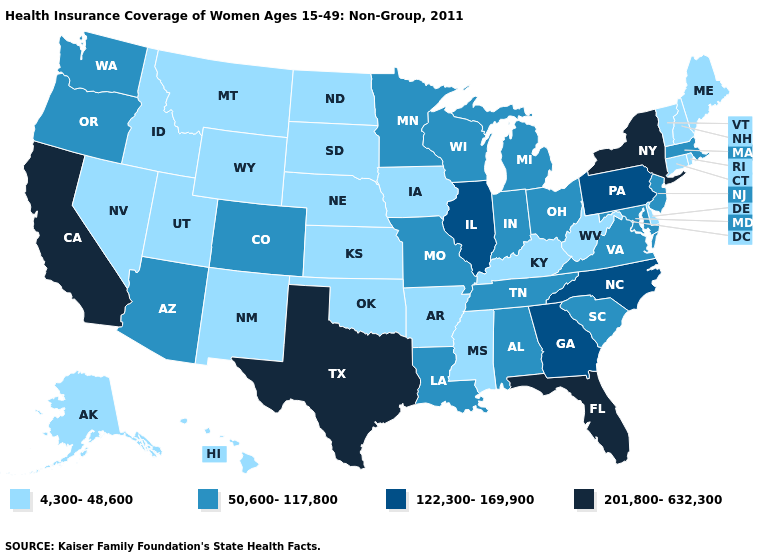Among the states that border Massachusetts , which have the lowest value?
Short answer required. Connecticut, New Hampshire, Rhode Island, Vermont. Among the states that border Nebraska , does Missouri have the highest value?
Quick response, please. Yes. Is the legend a continuous bar?
Short answer required. No. What is the highest value in the South ?
Short answer required. 201,800-632,300. What is the value of Georgia?
Answer briefly. 122,300-169,900. Which states have the lowest value in the USA?
Be succinct. Alaska, Arkansas, Connecticut, Delaware, Hawaii, Idaho, Iowa, Kansas, Kentucky, Maine, Mississippi, Montana, Nebraska, Nevada, New Hampshire, New Mexico, North Dakota, Oklahoma, Rhode Island, South Dakota, Utah, Vermont, West Virginia, Wyoming. Which states have the lowest value in the MidWest?
Write a very short answer. Iowa, Kansas, Nebraska, North Dakota, South Dakota. Does the first symbol in the legend represent the smallest category?
Be succinct. Yes. Name the states that have a value in the range 201,800-632,300?
Concise answer only. California, Florida, New York, Texas. Does Mississippi have the same value as West Virginia?
Concise answer only. Yes. What is the value of Washington?
Quick response, please. 50,600-117,800. What is the value of Michigan?
Concise answer only. 50,600-117,800. What is the value of Indiana?
Short answer required. 50,600-117,800. Name the states that have a value in the range 122,300-169,900?
Keep it brief. Georgia, Illinois, North Carolina, Pennsylvania. 